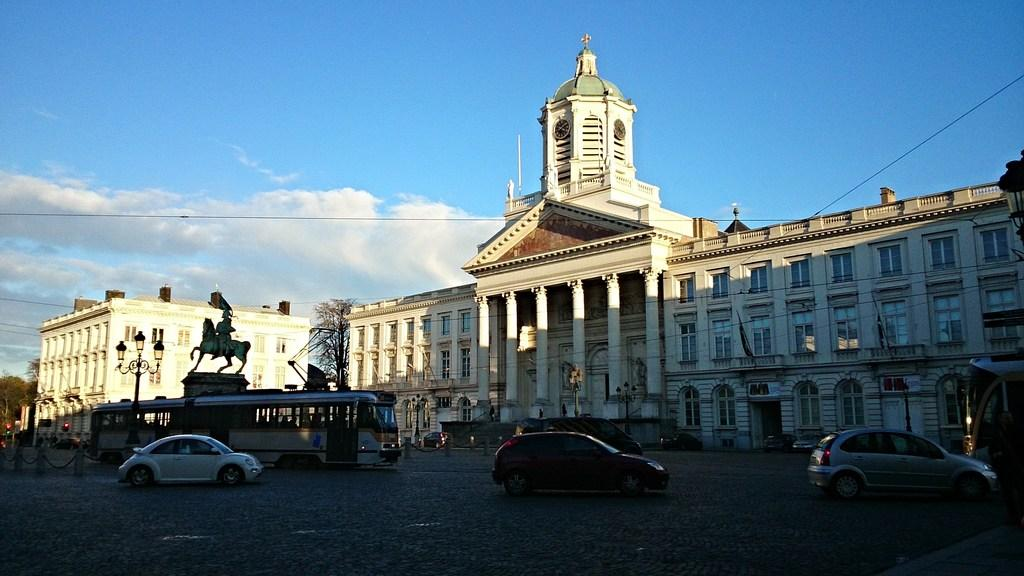What can be seen on the road in the image? There are vehicles on the road in the image. What structures are present to provide light at night? There are street lights visible in the image. What type of vegetation is present in the image? Trees are present in the image. What else can be seen in the image besides the trees? Wires are visible in the image. What is visible in the background of the image? There are buildings and the sky visible in the background of the image. Can you tell me how many toothbrushes are hanging from the wires in the image? There are no toothbrushes present in the image; only vehicles, street lights, trees, wires, buildings, and the sky are visible. What type of oil is being used by the vehicles in the image? There is no information about the type of oil being used by the vehicles in the image. 